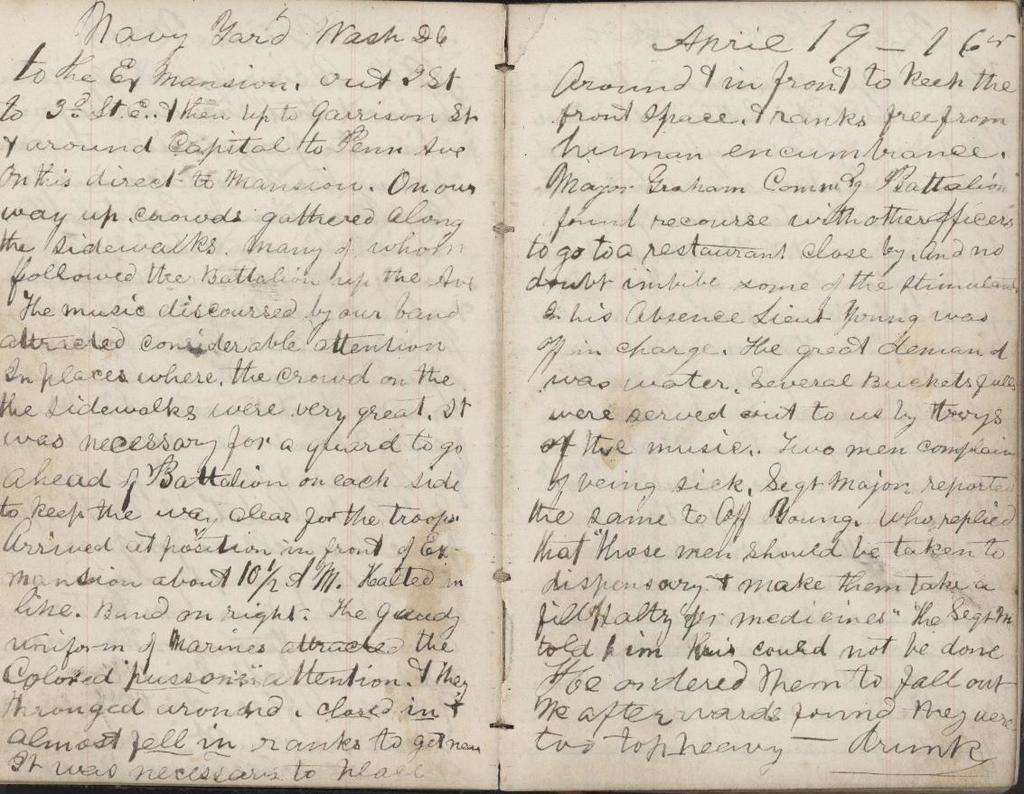<image>
Give a short and clear explanation of the subsequent image. an open book where some of the words are 'to the' 